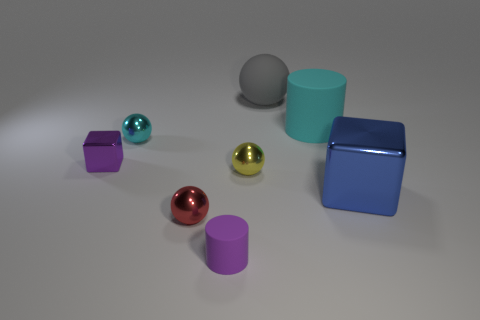How big is the purple rubber thing?
Give a very brief answer. Small. There is a matte cylinder that is on the right side of the rubber cylinder in front of the cyan cylinder; what is its color?
Give a very brief answer. Cyan. How many things are on the left side of the large blue thing and behind the tiny purple matte object?
Your response must be concise. 6. Are there more big blue metal objects than small cyan rubber blocks?
Keep it short and to the point. Yes. What is the material of the blue block?
Keep it short and to the point. Metal. There is a cylinder to the left of the big cylinder; what number of tiny purple rubber cylinders are left of it?
Ensure brevity in your answer.  0. There is a small metallic block; is its color the same as the rubber thing in front of the cyan shiny thing?
Provide a short and direct response. Yes. What is the color of the metallic cube that is the same size as the rubber sphere?
Your answer should be compact. Blue. Are there any big shiny objects of the same shape as the tiny purple shiny object?
Offer a terse response. Yes. Are there fewer large cylinders than metallic objects?
Provide a short and direct response. Yes. 